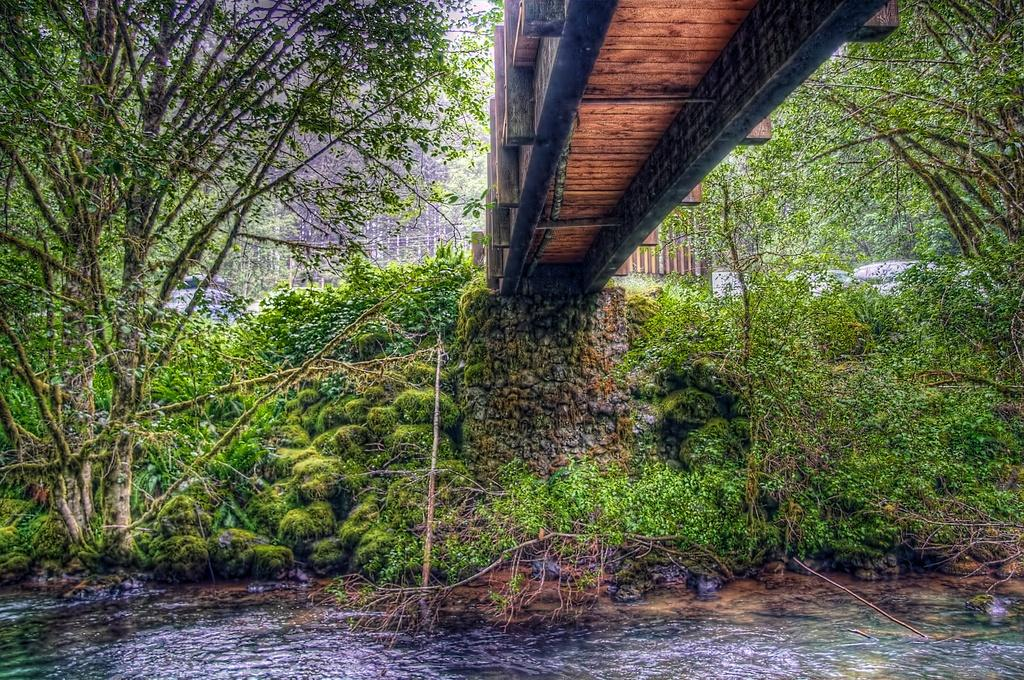What is located at the bottom of the image? There is a lake at the bottom of the image. What is above the lake in the image? There is a bridge above the lake. What can be seen in the background of the image? Trees are present in the background of the image. What type of rule is being enforced by the trees in the image? There is no rule being enforced by the trees in the image; they are simply part of the natural background. What songs can be heard being sung by the lake in the image? There is no indication of any songs being sung by the lake in the image; it is a still body of water. 